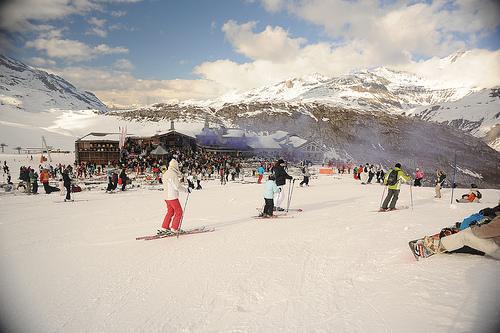How many people are wearing bathing suits?
Give a very brief answer. 0. 